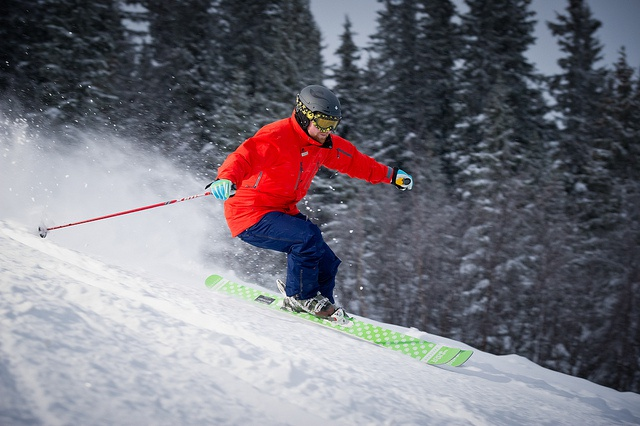Describe the objects in this image and their specific colors. I can see people in black, red, navy, and gray tones, skis in black, lightgray, lightgreen, and darkgray tones, and snowboard in black, lightgray, lightgreen, and darkgray tones in this image. 